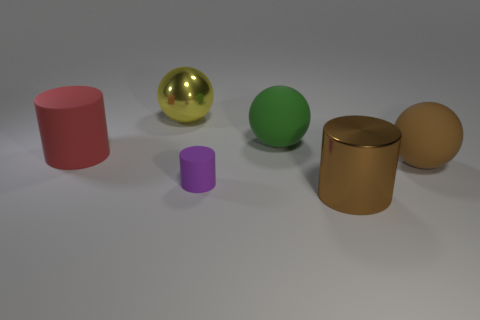What number of small things are blue metallic things or brown rubber objects?
Offer a very short reply. 0. Is the number of tiny purple rubber cylinders greater than the number of tiny gray cylinders?
Offer a terse response. Yes. Are the tiny purple thing and the big green sphere made of the same material?
Make the answer very short. Yes. Are there more shiny cylinders behind the yellow shiny thing than red things?
Provide a short and direct response. No. Do the big rubber cylinder and the large shiny sphere have the same color?
Provide a short and direct response. No. What number of other matte things are the same shape as the green rubber thing?
Make the answer very short. 1. There is a purple cylinder that is the same material as the large red object; what size is it?
Provide a short and direct response. Small. What color is the large thing that is both in front of the green sphere and on the left side of the purple rubber cylinder?
Make the answer very short. Red. How many purple objects have the same size as the brown rubber thing?
Provide a succinct answer. 0. What is the size of the rubber object that is the same color as the metallic cylinder?
Provide a short and direct response. Large. 